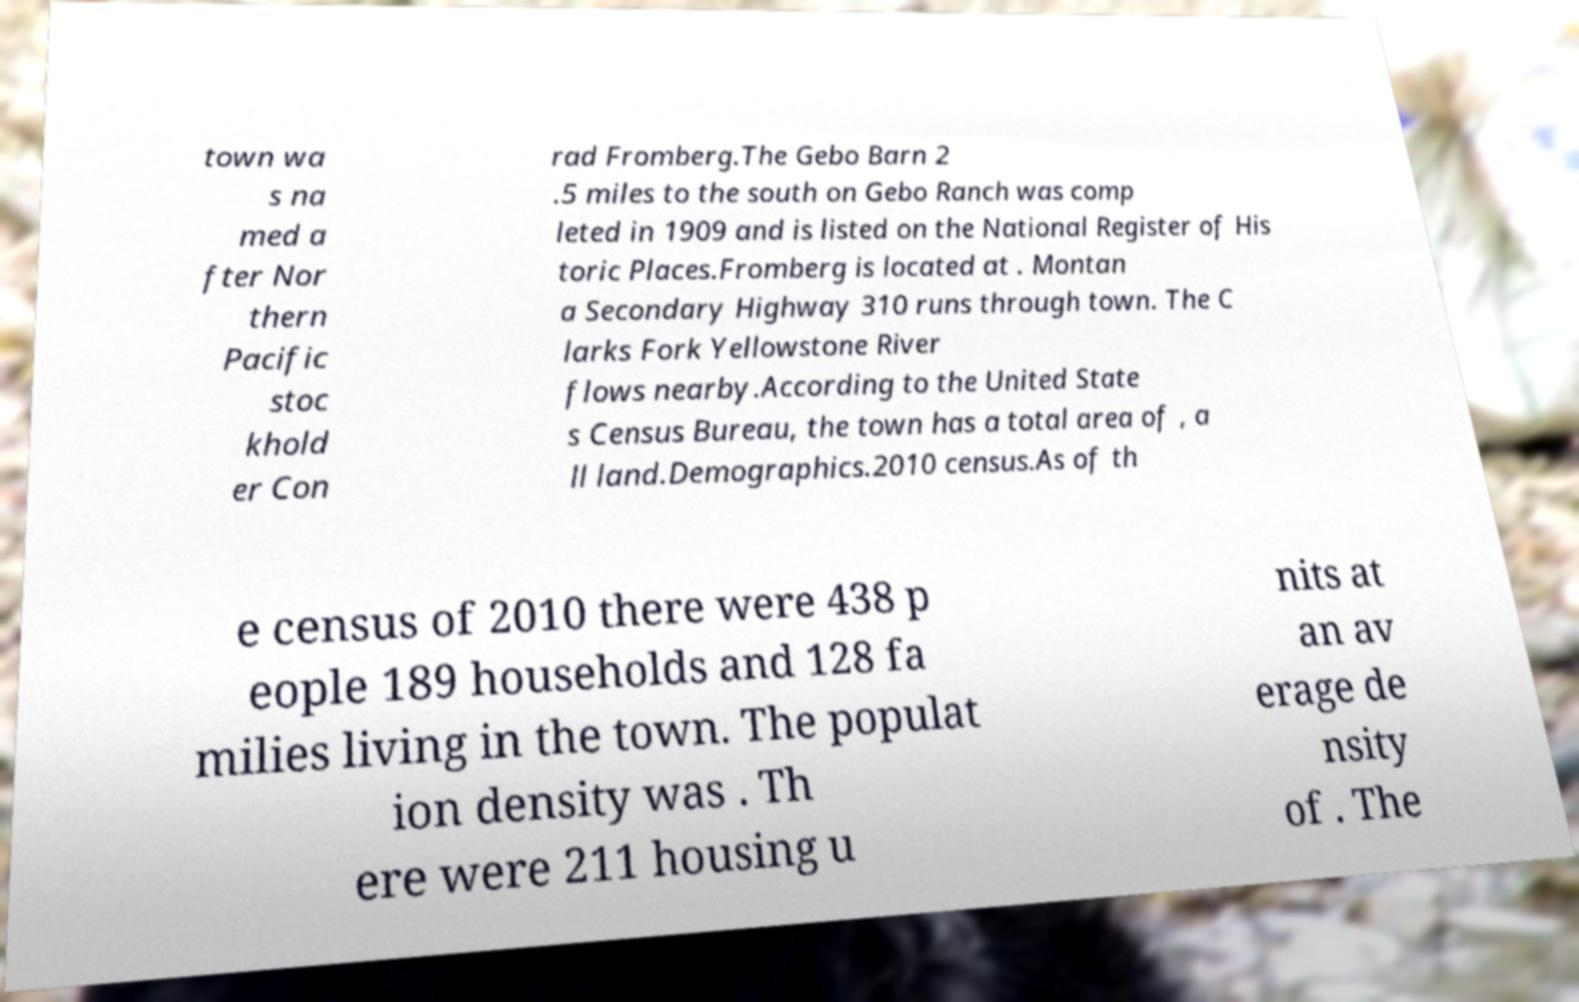Could you assist in decoding the text presented in this image and type it out clearly? town wa s na med a fter Nor thern Pacific stoc khold er Con rad Fromberg.The Gebo Barn 2 .5 miles to the south on Gebo Ranch was comp leted in 1909 and is listed on the National Register of His toric Places.Fromberg is located at . Montan a Secondary Highway 310 runs through town. The C larks Fork Yellowstone River flows nearby.According to the United State s Census Bureau, the town has a total area of , a ll land.Demographics.2010 census.As of th e census of 2010 there were 438 p eople 189 households and 128 fa milies living in the town. The populat ion density was . Th ere were 211 housing u nits at an av erage de nsity of . The 